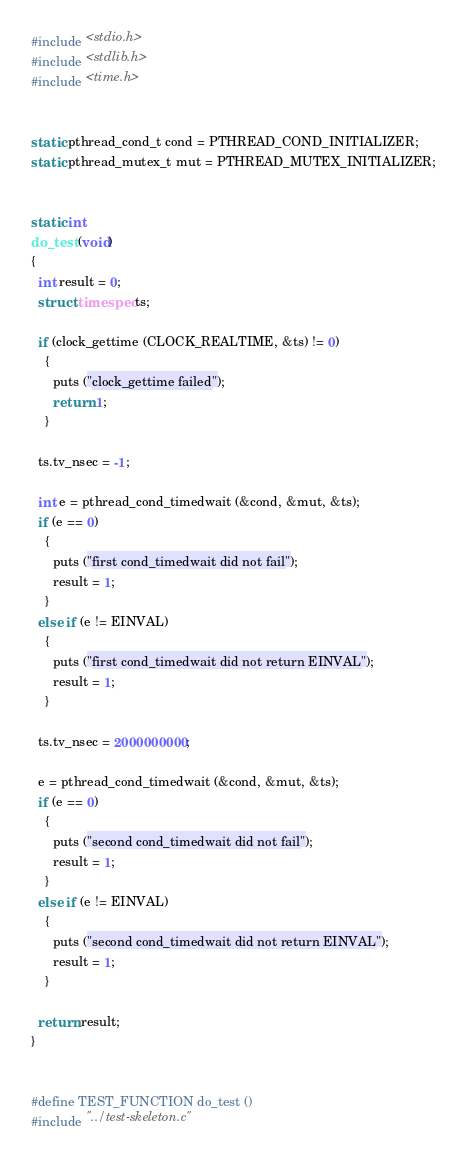Convert code to text. <code><loc_0><loc_0><loc_500><loc_500><_C_>#include <stdio.h>
#include <stdlib.h>
#include <time.h>


static pthread_cond_t cond = PTHREAD_COND_INITIALIZER;
static pthread_mutex_t mut = PTHREAD_MUTEX_INITIALIZER;


static int
do_test (void)
{
  int result = 0;
  struct timespec ts;

  if (clock_gettime (CLOCK_REALTIME, &ts) != 0)
    {
      puts ("clock_gettime failed");
      return 1;
    }

  ts.tv_nsec = -1;

  int e = pthread_cond_timedwait (&cond, &mut, &ts);
  if (e == 0)
    {
      puts ("first cond_timedwait did not fail");
      result = 1;
    }
  else if (e != EINVAL)
    {
      puts ("first cond_timedwait did not return EINVAL");
      result = 1;
    }

  ts.tv_nsec = 2000000000;

  e = pthread_cond_timedwait (&cond, &mut, &ts);
  if (e == 0)
    {
      puts ("second cond_timedwait did not fail");
      result = 1;
    }
  else if (e != EINVAL)
    {
      puts ("second cond_timedwait did not return EINVAL");
      result = 1;
    }

  return result;
}


#define TEST_FUNCTION do_test ()
#include "../test-skeleton.c"
</code> 